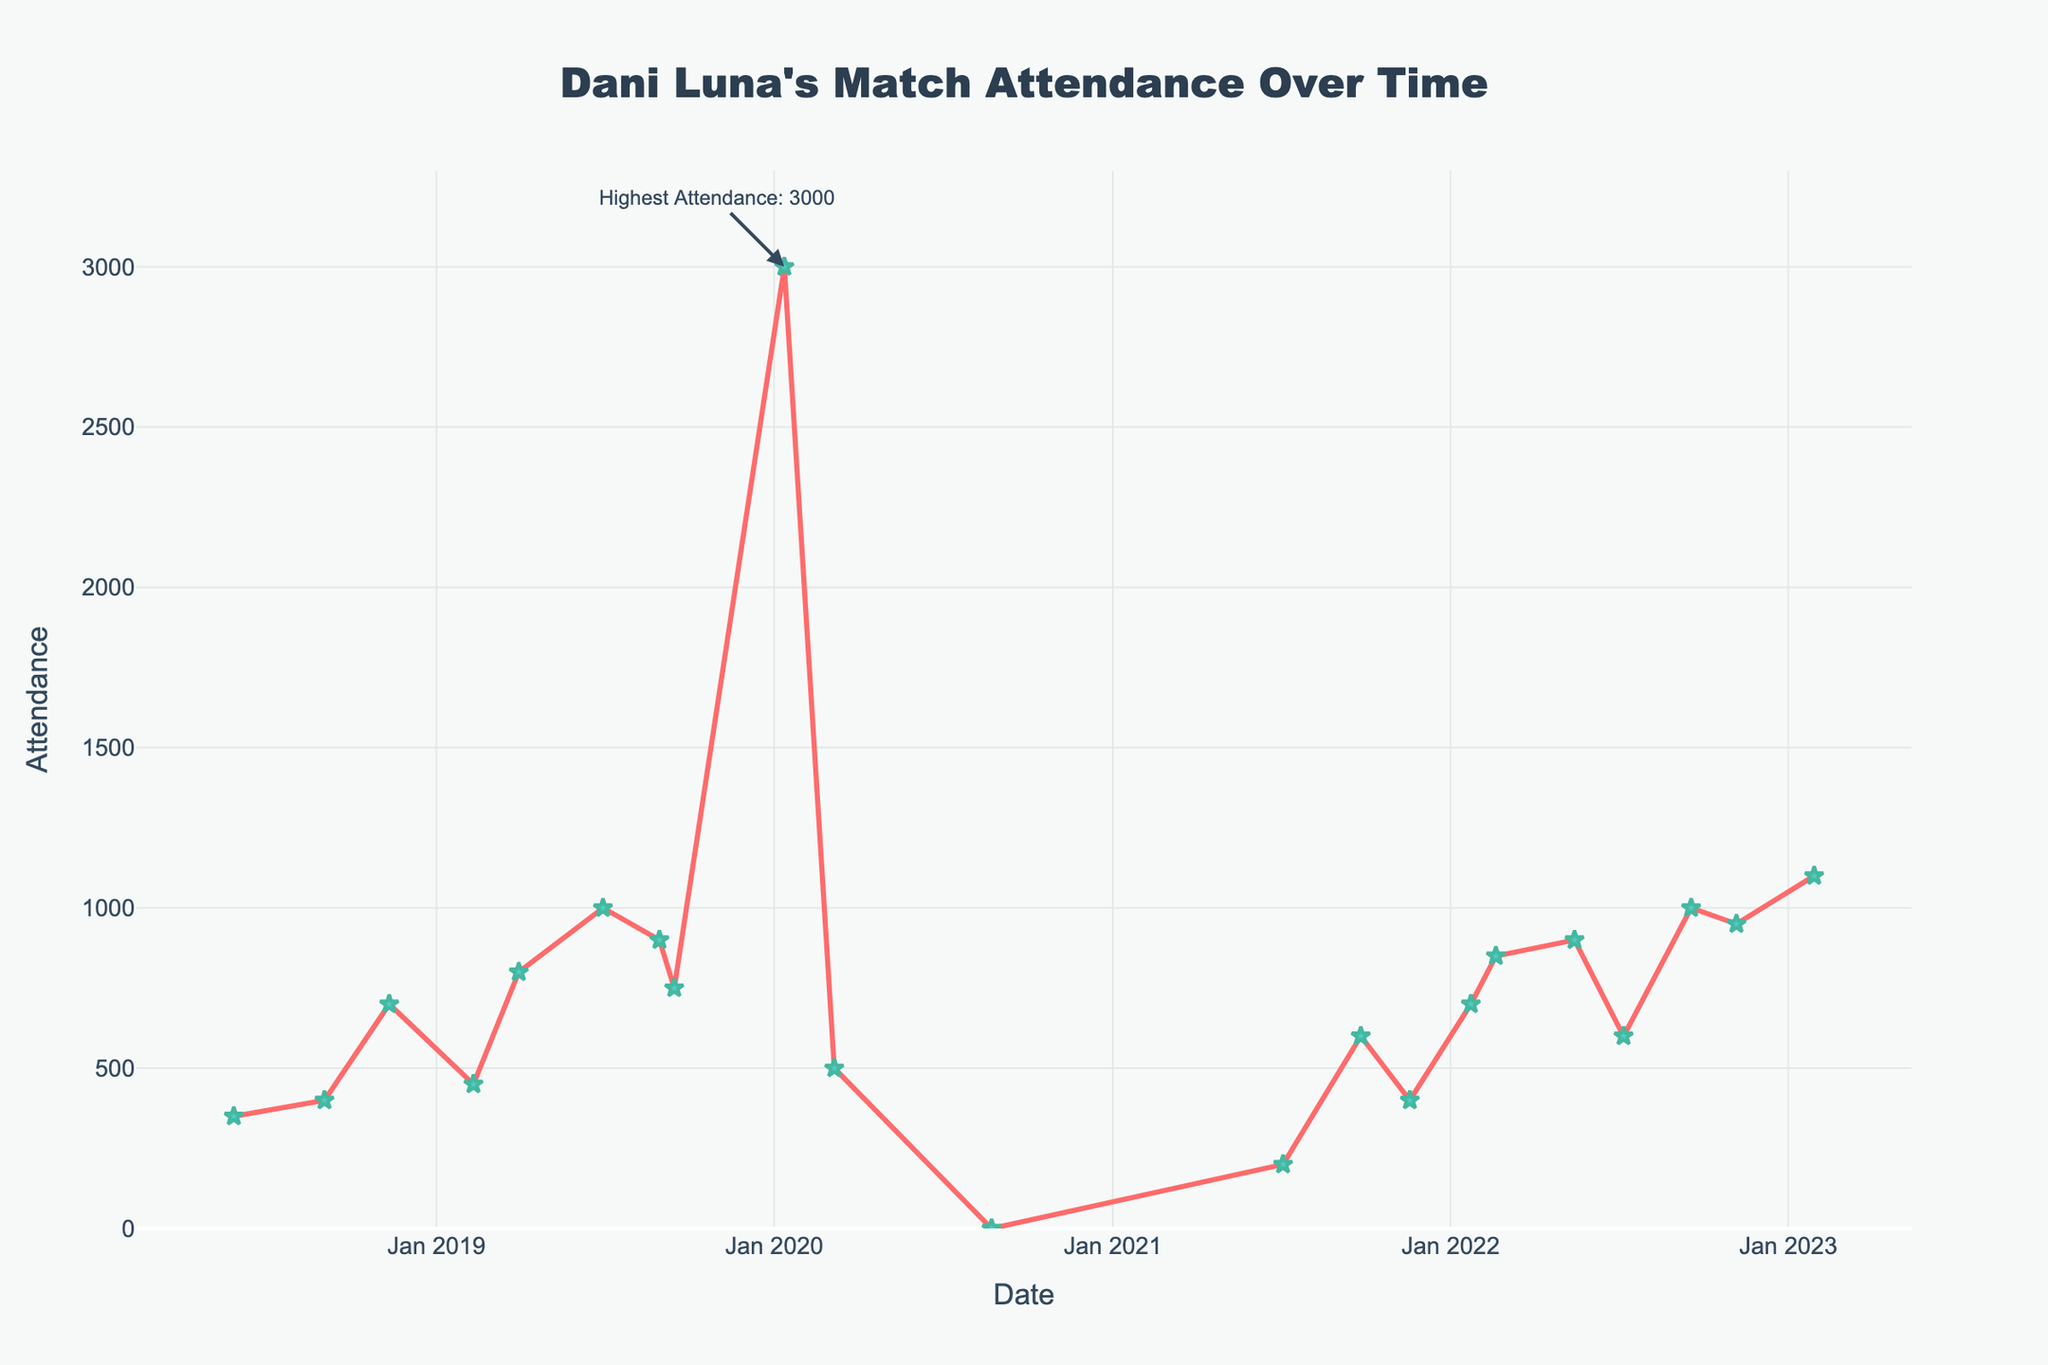What is the highest attendance recorded for Dani Luna's matches? The highest attendance can be found at the peak of the line chart where an annotation is present. The annotation indicates "Highest Attendance: 3000", which is the maximum audience turnout.
Answer: 3000 What is the attendance at "PROGRESS Chapter 104" on August 23, 2020? Locate the "PROGRESS Chapter 104" event on the timeline (August 23, 2020) and refer to the y-axis. The value is zero.
Answer: 0 How does the attendance for "EVE Wrestle Queendom 2" compare to "NXT UK TakeOver: Blackpool II"? Find the attendance values for both events on the chart. "EVE Wrestle Queendom 2" has an attendance of 1000, while "NXT UK TakeOver: Blackpool II" has an attendance of 3000. Compare these values: 3000 is greater than 1000.
Answer: "NXT UK TakeOver: Blackpool II" had a higher attendance What is the average attendance for Dani Luna's matches in 2022? Identify all events in 2022 and note their attendances: 700, 850, 900, 600, 1000, 950, 1100. Sum these values (700 + 850 + 900 + 600 + 1000 + 950 + 1100 = 6100) and divide by the number of events (7). The average attendance is 6100 / 7 = 871 (approximately).
Answer: 871 Which event just before the pandemic had the highest attendance, and what was the value? Look for events leading up to early 2020. The last event before the pandemic is "NXT UK TV Taping" on March 6, 2020, with an attendance of 500. The highest attendance before this event is "NXT UK TakeOver: Blackpool II" with 3000.
Answer: "NXT UK TakeOver: Blackpool II", 3000 How many events had attendances greater than or equal to 900? Count the data points on the y-axis that are equal to or above 900: 1000, 3000, 900, 950, 1100. There are 5 such events.
Answer: 5 What is the median attendance for Dani Luna's matches? List the attendances in ascending order: 0, 200, 350, 400, 400, 450, 500, 600, 600, 700, 700, 750, 800, 850, 900, 900, 950, 1000, 1100, 3000. There are 20 values. The median is the average of the 10th and 11th values: (600 + 700) / 2 = 650.
Answer: 650 Which year had the highest average attendance? Compare the average attendance for each year by summing the attendances and dividing by the number of events: 
2018: (350 + 400 + 700) / 3 = 483.33 
2019: (450 + 800 + 1000 + 900 + 750) / 5 = 780 
2020: (3000 + 500 + 0) / 3 = 1166.67 
2021: (200 + 600 + 400) / 3 = 400 
2022: (700 + 850 + 900 + 600 + 1000 + 950 + 1100) / 7 = 871.43 
2020 has the highest average attendance.
Answer: 2020 